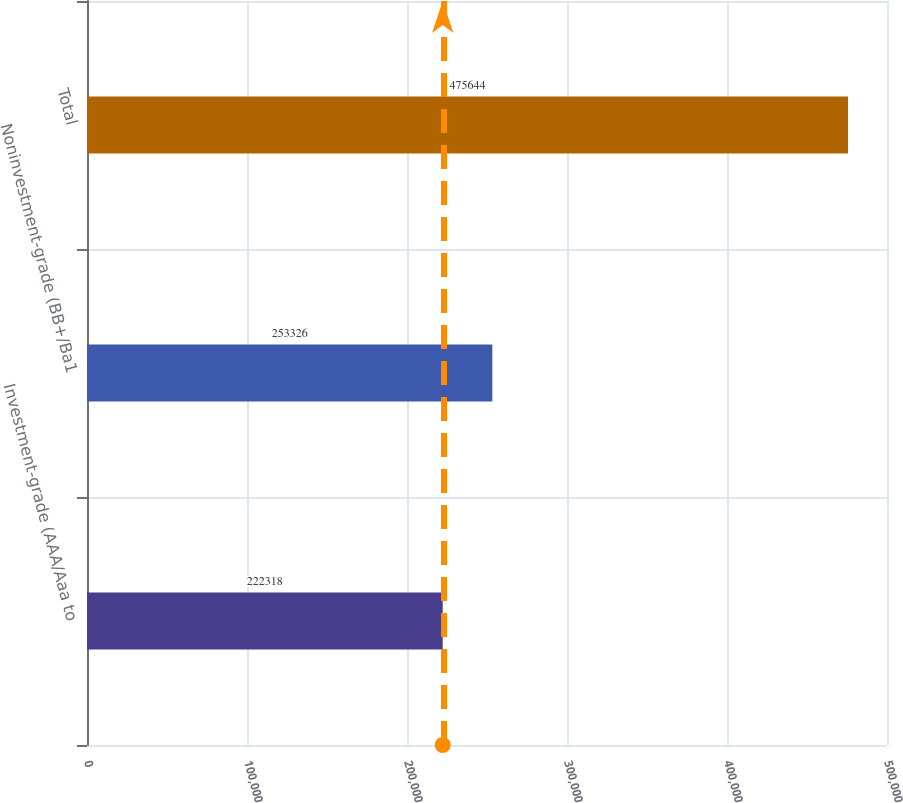Convert chart. <chart><loc_0><loc_0><loc_500><loc_500><bar_chart><fcel>Investment-grade (AAA/Aaa to<fcel>Noninvestment-grade (BB+/Ba1<fcel>Total<nl><fcel>222318<fcel>253326<fcel>475644<nl></chart> 